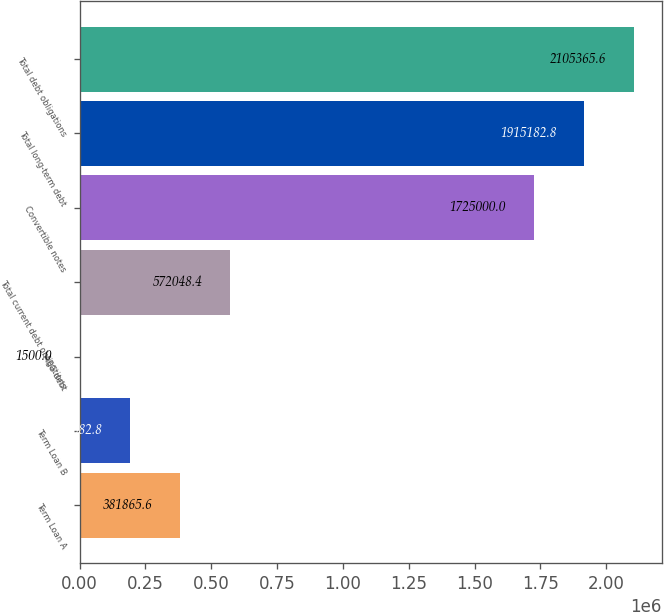Convert chart. <chart><loc_0><loc_0><loc_500><loc_500><bar_chart><fcel>Term Loan A<fcel>Term Loan B<fcel>AEG debt<fcel>Total current debt obligations<fcel>Convertible notes<fcel>Total long-term debt<fcel>Total debt obligations<nl><fcel>381866<fcel>191683<fcel>1500<fcel>572048<fcel>1.725e+06<fcel>1.91518e+06<fcel>2.10537e+06<nl></chart> 